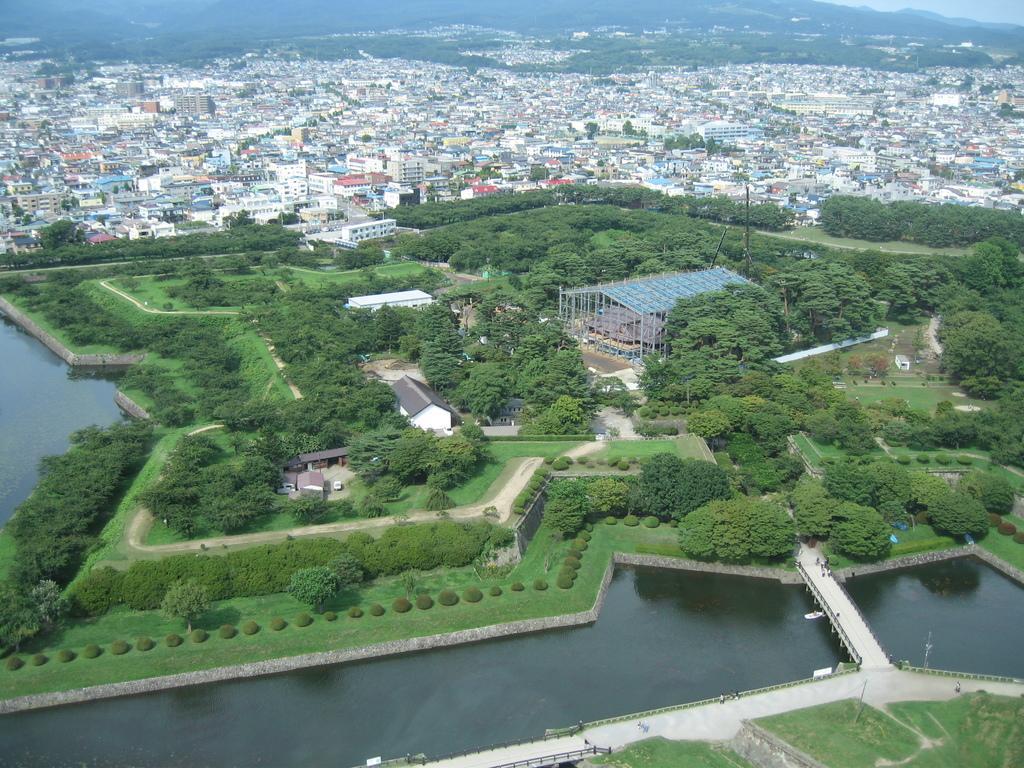Please provide a concise description of this image. In this picture we can see grass, trees, plants, sheds, water and a bridge in the front, in the background there are some buildings and trees, we can see the sky at the right top of the picture. 